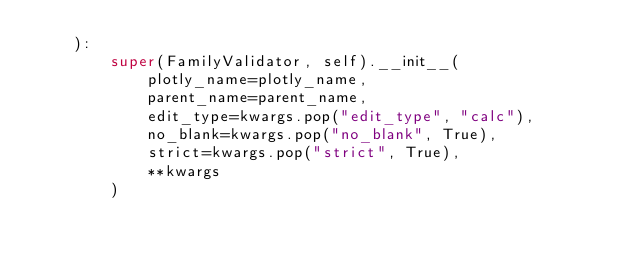Convert code to text. <code><loc_0><loc_0><loc_500><loc_500><_Python_>    ):
        super(FamilyValidator, self).__init__(
            plotly_name=plotly_name,
            parent_name=parent_name,
            edit_type=kwargs.pop("edit_type", "calc"),
            no_blank=kwargs.pop("no_blank", True),
            strict=kwargs.pop("strict", True),
            **kwargs
        )
</code> 